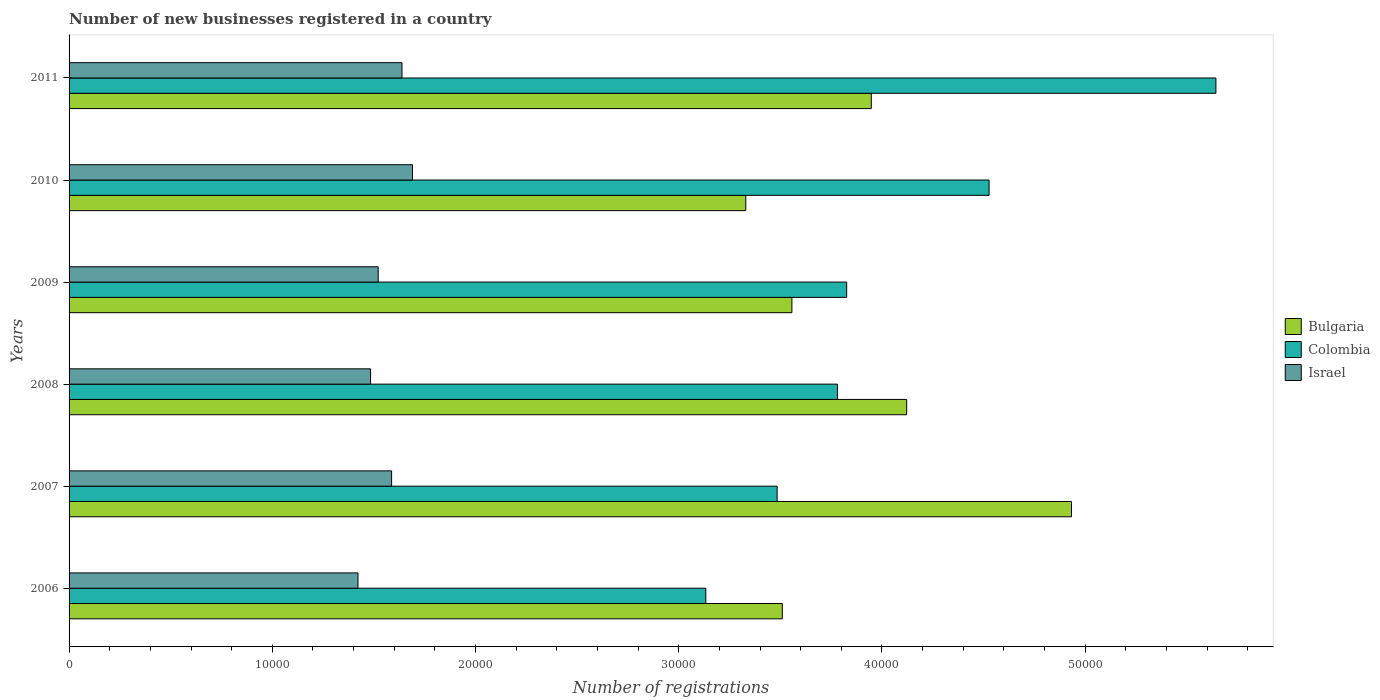How many different coloured bars are there?
Your answer should be very brief. 3. Are the number of bars on each tick of the Y-axis equal?
Ensure brevity in your answer.  Yes. How many bars are there on the 2nd tick from the bottom?
Your answer should be compact. 3. What is the number of new businesses registered in Colombia in 2007?
Offer a very short reply. 3.48e+04. Across all years, what is the maximum number of new businesses registered in Bulgaria?
Your answer should be very brief. 4.93e+04. Across all years, what is the minimum number of new businesses registered in Israel?
Your answer should be compact. 1.42e+04. In which year was the number of new businesses registered in Bulgaria maximum?
Provide a short and direct response. 2007. In which year was the number of new businesses registered in Israel minimum?
Your answer should be very brief. 2006. What is the total number of new businesses registered in Colombia in the graph?
Make the answer very short. 2.44e+05. What is the difference between the number of new businesses registered in Colombia in 2009 and that in 2010?
Ensure brevity in your answer.  -7008. What is the difference between the number of new businesses registered in Israel in 2010 and the number of new businesses registered in Bulgaria in 2007?
Your answer should be compact. -3.24e+04. What is the average number of new businesses registered in Israel per year?
Your response must be concise. 1.56e+04. In the year 2008, what is the difference between the number of new businesses registered in Colombia and number of new businesses registered in Israel?
Make the answer very short. 2.30e+04. In how many years, is the number of new businesses registered in Colombia greater than 6000 ?
Provide a short and direct response. 6. What is the ratio of the number of new businesses registered in Bulgaria in 2007 to that in 2009?
Your answer should be compact. 1.39. Is the number of new businesses registered in Israel in 2006 less than that in 2011?
Ensure brevity in your answer.  Yes. Is the difference between the number of new businesses registered in Colombia in 2007 and 2011 greater than the difference between the number of new businesses registered in Israel in 2007 and 2011?
Make the answer very short. No. What is the difference between the highest and the second highest number of new businesses registered in Colombia?
Provide a short and direct response. 1.12e+04. What is the difference between the highest and the lowest number of new businesses registered in Israel?
Make the answer very short. 2681. In how many years, is the number of new businesses registered in Israel greater than the average number of new businesses registered in Israel taken over all years?
Provide a succinct answer. 3. Are all the bars in the graph horizontal?
Make the answer very short. Yes. What is the difference between two consecutive major ticks on the X-axis?
Make the answer very short. 10000. Are the values on the major ticks of X-axis written in scientific E-notation?
Keep it short and to the point. No. Does the graph contain grids?
Make the answer very short. No. Where does the legend appear in the graph?
Offer a terse response. Center right. How many legend labels are there?
Ensure brevity in your answer.  3. What is the title of the graph?
Provide a succinct answer. Number of new businesses registered in a country. Does "Barbados" appear as one of the legend labels in the graph?
Offer a terse response. No. What is the label or title of the X-axis?
Your answer should be compact. Number of registrations. What is the label or title of the Y-axis?
Your response must be concise. Years. What is the Number of registrations of Bulgaria in 2006?
Offer a very short reply. 3.51e+04. What is the Number of registrations of Colombia in 2006?
Your answer should be compact. 3.13e+04. What is the Number of registrations of Israel in 2006?
Your response must be concise. 1.42e+04. What is the Number of registrations of Bulgaria in 2007?
Your answer should be compact. 4.93e+04. What is the Number of registrations in Colombia in 2007?
Provide a short and direct response. 3.48e+04. What is the Number of registrations in Israel in 2007?
Offer a terse response. 1.59e+04. What is the Number of registrations in Bulgaria in 2008?
Make the answer very short. 4.12e+04. What is the Number of registrations in Colombia in 2008?
Your answer should be very brief. 3.78e+04. What is the Number of registrations of Israel in 2008?
Give a very brief answer. 1.48e+04. What is the Number of registrations in Bulgaria in 2009?
Ensure brevity in your answer.  3.56e+04. What is the Number of registrations in Colombia in 2009?
Your answer should be very brief. 3.83e+04. What is the Number of registrations in Israel in 2009?
Your answer should be compact. 1.52e+04. What is the Number of registrations in Bulgaria in 2010?
Keep it short and to the point. 3.33e+04. What is the Number of registrations in Colombia in 2010?
Offer a terse response. 4.53e+04. What is the Number of registrations of Israel in 2010?
Make the answer very short. 1.69e+04. What is the Number of registrations in Bulgaria in 2011?
Keep it short and to the point. 3.95e+04. What is the Number of registrations in Colombia in 2011?
Offer a terse response. 5.64e+04. What is the Number of registrations in Israel in 2011?
Offer a very short reply. 1.64e+04. Across all years, what is the maximum Number of registrations of Bulgaria?
Provide a short and direct response. 4.93e+04. Across all years, what is the maximum Number of registrations of Colombia?
Offer a very short reply. 5.64e+04. Across all years, what is the maximum Number of registrations in Israel?
Your answer should be very brief. 1.69e+04. Across all years, what is the minimum Number of registrations in Bulgaria?
Keep it short and to the point. 3.33e+04. Across all years, what is the minimum Number of registrations of Colombia?
Your answer should be very brief. 3.13e+04. Across all years, what is the minimum Number of registrations of Israel?
Keep it short and to the point. 1.42e+04. What is the total Number of registrations in Bulgaria in the graph?
Keep it short and to the point. 2.34e+05. What is the total Number of registrations of Colombia in the graph?
Your response must be concise. 2.44e+05. What is the total Number of registrations of Israel in the graph?
Your response must be concise. 9.34e+04. What is the difference between the Number of registrations of Bulgaria in 2006 and that in 2007?
Provide a short and direct response. -1.42e+04. What is the difference between the Number of registrations in Colombia in 2006 and that in 2007?
Ensure brevity in your answer.  -3510. What is the difference between the Number of registrations in Israel in 2006 and that in 2007?
Offer a very short reply. -1654. What is the difference between the Number of registrations of Bulgaria in 2006 and that in 2008?
Offer a terse response. -6120. What is the difference between the Number of registrations of Colombia in 2006 and that in 2008?
Offer a very short reply. -6477. What is the difference between the Number of registrations in Israel in 2006 and that in 2008?
Make the answer very short. -619. What is the difference between the Number of registrations in Bulgaria in 2006 and that in 2009?
Your response must be concise. -472. What is the difference between the Number of registrations in Colombia in 2006 and that in 2009?
Make the answer very short. -6932. What is the difference between the Number of registrations in Israel in 2006 and that in 2009?
Make the answer very short. -994. What is the difference between the Number of registrations in Bulgaria in 2006 and that in 2010?
Your answer should be compact. 1798. What is the difference between the Number of registrations of Colombia in 2006 and that in 2010?
Your answer should be very brief. -1.39e+04. What is the difference between the Number of registrations in Israel in 2006 and that in 2010?
Provide a short and direct response. -2681. What is the difference between the Number of registrations of Bulgaria in 2006 and that in 2011?
Your answer should be very brief. -4378. What is the difference between the Number of registrations of Colombia in 2006 and that in 2011?
Keep it short and to the point. -2.51e+04. What is the difference between the Number of registrations in Israel in 2006 and that in 2011?
Make the answer very short. -2166. What is the difference between the Number of registrations in Bulgaria in 2007 and that in 2008?
Provide a succinct answer. 8110. What is the difference between the Number of registrations in Colombia in 2007 and that in 2008?
Keep it short and to the point. -2967. What is the difference between the Number of registrations of Israel in 2007 and that in 2008?
Your answer should be compact. 1035. What is the difference between the Number of registrations of Bulgaria in 2007 and that in 2009?
Ensure brevity in your answer.  1.38e+04. What is the difference between the Number of registrations of Colombia in 2007 and that in 2009?
Offer a very short reply. -3422. What is the difference between the Number of registrations in Israel in 2007 and that in 2009?
Provide a short and direct response. 660. What is the difference between the Number of registrations in Bulgaria in 2007 and that in 2010?
Make the answer very short. 1.60e+04. What is the difference between the Number of registrations in Colombia in 2007 and that in 2010?
Offer a very short reply. -1.04e+04. What is the difference between the Number of registrations in Israel in 2007 and that in 2010?
Provide a succinct answer. -1027. What is the difference between the Number of registrations of Bulgaria in 2007 and that in 2011?
Keep it short and to the point. 9852. What is the difference between the Number of registrations of Colombia in 2007 and that in 2011?
Your answer should be compact. -2.16e+04. What is the difference between the Number of registrations in Israel in 2007 and that in 2011?
Your answer should be compact. -512. What is the difference between the Number of registrations in Bulgaria in 2008 and that in 2009?
Ensure brevity in your answer.  5648. What is the difference between the Number of registrations in Colombia in 2008 and that in 2009?
Give a very brief answer. -455. What is the difference between the Number of registrations of Israel in 2008 and that in 2009?
Ensure brevity in your answer.  -375. What is the difference between the Number of registrations in Bulgaria in 2008 and that in 2010?
Offer a very short reply. 7918. What is the difference between the Number of registrations in Colombia in 2008 and that in 2010?
Your response must be concise. -7463. What is the difference between the Number of registrations in Israel in 2008 and that in 2010?
Ensure brevity in your answer.  -2062. What is the difference between the Number of registrations in Bulgaria in 2008 and that in 2011?
Offer a very short reply. 1742. What is the difference between the Number of registrations in Colombia in 2008 and that in 2011?
Provide a succinct answer. -1.86e+04. What is the difference between the Number of registrations in Israel in 2008 and that in 2011?
Make the answer very short. -1547. What is the difference between the Number of registrations in Bulgaria in 2009 and that in 2010?
Provide a succinct answer. 2270. What is the difference between the Number of registrations in Colombia in 2009 and that in 2010?
Offer a terse response. -7008. What is the difference between the Number of registrations in Israel in 2009 and that in 2010?
Your answer should be compact. -1687. What is the difference between the Number of registrations in Bulgaria in 2009 and that in 2011?
Ensure brevity in your answer.  -3906. What is the difference between the Number of registrations of Colombia in 2009 and that in 2011?
Provide a short and direct response. -1.82e+04. What is the difference between the Number of registrations of Israel in 2009 and that in 2011?
Offer a very short reply. -1172. What is the difference between the Number of registrations in Bulgaria in 2010 and that in 2011?
Give a very brief answer. -6176. What is the difference between the Number of registrations in Colombia in 2010 and that in 2011?
Offer a terse response. -1.12e+04. What is the difference between the Number of registrations in Israel in 2010 and that in 2011?
Offer a terse response. 515. What is the difference between the Number of registrations of Bulgaria in 2006 and the Number of registrations of Colombia in 2007?
Offer a terse response. 255. What is the difference between the Number of registrations in Bulgaria in 2006 and the Number of registrations in Israel in 2007?
Give a very brief answer. 1.92e+04. What is the difference between the Number of registrations of Colombia in 2006 and the Number of registrations of Israel in 2007?
Your answer should be very brief. 1.55e+04. What is the difference between the Number of registrations of Bulgaria in 2006 and the Number of registrations of Colombia in 2008?
Provide a succinct answer. -2712. What is the difference between the Number of registrations of Bulgaria in 2006 and the Number of registrations of Israel in 2008?
Ensure brevity in your answer.  2.03e+04. What is the difference between the Number of registrations in Colombia in 2006 and the Number of registrations in Israel in 2008?
Ensure brevity in your answer.  1.65e+04. What is the difference between the Number of registrations in Bulgaria in 2006 and the Number of registrations in Colombia in 2009?
Provide a succinct answer. -3167. What is the difference between the Number of registrations of Bulgaria in 2006 and the Number of registrations of Israel in 2009?
Offer a very short reply. 1.99e+04. What is the difference between the Number of registrations in Colombia in 2006 and the Number of registrations in Israel in 2009?
Keep it short and to the point. 1.61e+04. What is the difference between the Number of registrations in Bulgaria in 2006 and the Number of registrations in Colombia in 2010?
Your answer should be very brief. -1.02e+04. What is the difference between the Number of registrations in Bulgaria in 2006 and the Number of registrations in Israel in 2010?
Your answer should be very brief. 1.82e+04. What is the difference between the Number of registrations in Colombia in 2006 and the Number of registrations in Israel in 2010?
Offer a very short reply. 1.44e+04. What is the difference between the Number of registrations in Bulgaria in 2006 and the Number of registrations in Colombia in 2011?
Your response must be concise. -2.13e+04. What is the difference between the Number of registrations of Bulgaria in 2006 and the Number of registrations of Israel in 2011?
Your answer should be very brief. 1.87e+04. What is the difference between the Number of registrations in Colombia in 2006 and the Number of registrations in Israel in 2011?
Ensure brevity in your answer.  1.50e+04. What is the difference between the Number of registrations of Bulgaria in 2007 and the Number of registrations of Colombia in 2008?
Make the answer very short. 1.15e+04. What is the difference between the Number of registrations of Bulgaria in 2007 and the Number of registrations of Israel in 2008?
Give a very brief answer. 3.45e+04. What is the difference between the Number of registrations in Colombia in 2007 and the Number of registrations in Israel in 2008?
Provide a succinct answer. 2.00e+04. What is the difference between the Number of registrations of Bulgaria in 2007 and the Number of registrations of Colombia in 2009?
Give a very brief answer. 1.11e+04. What is the difference between the Number of registrations of Bulgaria in 2007 and the Number of registrations of Israel in 2009?
Offer a very short reply. 3.41e+04. What is the difference between the Number of registrations of Colombia in 2007 and the Number of registrations of Israel in 2009?
Offer a very short reply. 1.96e+04. What is the difference between the Number of registrations of Bulgaria in 2007 and the Number of registrations of Colombia in 2010?
Offer a very short reply. 4055. What is the difference between the Number of registrations of Bulgaria in 2007 and the Number of registrations of Israel in 2010?
Offer a terse response. 3.24e+04. What is the difference between the Number of registrations of Colombia in 2007 and the Number of registrations of Israel in 2010?
Provide a succinct answer. 1.79e+04. What is the difference between the Number of registrations of Bulgaria in 2007 and the Number of registrations of Colombia in 2011?
Offer a terse response. -7106. What is the difference between the Number of registrations of Bulgaria in 2007 and the Number of registrations of Israel in 2011?
Offer a terse response. 3.29e+04. What is the difference between the Number of registrations in Colombia in 2007 and the Number of registrations in Israel in 2011?
Ensure brevity in your answer.  1.85e+04. What is the difference between the Number of registrations of Bulgaria in 2008 and the Number of registrations of Colombia in 2009?
Keep it short and to the point. 2953. What is the difference between the Number of registrations in Bulgaria in 2008 and the Number of registrations in Israel in 2009?
Your response must be concise. 2.60e+04. What is the difference between the Number of registrations in Colombia in 2008 and the Number of registrations in Israel in 2009?
Make the answer very short. 2.26e+04. What is the difference between the Number of registrations of Bulgaria in 2008 and the Number of registrations of Colombia in 2010?
Provide a short and direct response. -4055. What is the difference between the Number of registrations of Bulgaria in 2008 and the Number of registrations of Israel in 2010?
Provide a succinct answer. 2.43e+04. What is the difference between the Number of registrations of Colombia in 2008 and the Number of registrations of Israel in 2010?
Keep it short and to the point. 2.09e+04. What is the difference between the Number of registrations of Bulgaria in 2008 and the Number of registrations of Colombia in 2011?
Keep it short and to the point. -1.52e+04. What is the difference between the Number of registrations of Bulgaria in 2008 and the Number of registrations of Israel in 2011?
Provide a succinct answer. 2.48e+04. What is the difference between the Number of registrations of Colombia in 2008 and the Number of registrations of Israel in 2011?
Your answer should be very brief. 2.14e+04. What is the difference between the Number of registrations in Bulgaria in 2009 and the Number of registrations in Colombia in 2010?
Your response must be concise. -9703. What is the difference between the Number of registrations of Bulgaria in 2009 and the Number of registrations of Israel in 2010?
Make the answer very short. 1.87e+04. What is the difference between the Number of registrations of Colombia in 2009 and the Number of registrations of Israel in 2010?
Your answer should be compact. 2.14e+04. What is the difference between the Number of registrations of Bulgaria in 2009 and the Number of registrations of Colombia in 2011?
Give a very brief answer. -2.09e+04. What is the difference between the Number of registrations in Bulgaria in 2009 and the Number of registrations in Israel in 2011?
Offer a very short reply. 1.92e+04. What is the difference between the Number of registrations of Colombia in 2009 and the Number of registrations of Israel in 2011?
Provide a succinct answer. 2.19e+04. What is the difference between the Number of registrations in Bulgaria in 2010 and the Number of registrations in Colombia in 2011?
Provide a succinct answer. -2.31e+04. What is the difference between the Number of registrations in Bulgaria in 2010 and the Number of registrations in Israel in 2011?
Offer a very short reply. 1.69e+04. What is the difference between the Number of registrations in Colombia in 2010 and the Number of registrations in Israel in 2011?
Your answer should be very brief. 2.89e+04. What is the average Number of registrations of Bulgaria per year?
Keep it short and to the point. 3.90e+04. What is the average Number of registrations in Colombia per year?
Make the answer very short. 4.07e+04. What is the average Number of registrations of Israel per year?
Give a very brief answer. 1.56e+04. In the year 2006, what is the difference between the Number of registrations in Bulgaria and Number of registrations in Colombia?
Offer a very short reply. 3765. In the year 2006, what is the difference between the Number of registrations of Bulgaria and Number of registrations of Israel?
Ensure brevity in your answer.  2.09e+04. In the year 2006, what is the difference between the Number of registrations in Colombia and Number of registrations in Israel?
Offer a terse response. 1.71e+04. In the year 2007, what is the difference between the Number of registrations of Bulgaria and Number of registrations of Colombia?
Your answer should be very brief. 1.45e+04. In the year 2007, what is the difference between the Number of registrations of Bulgaria and Number of registrations of Israel?
Provide a succinct answer. 3.35e+04. In the year 2007, what is the difference between the Number of registrations of Colombia and Number of registrations of Israel?
Make the answer very short. 1.90e+04. In the year 2008, what is the difference between the Number of registrations in Bulgaria and Number of registrations in Colombia?
Ensure brevity in your answer.  3408. In the year 2008, what is the difference between the Number of registrations in Bulgaria and Number of registrations in Israel?
Ensure brevity in your answer.  2.64e+04. In the year 2008, what is the difference between the Number of registrations in Colombia and Number of registrations in Israel?
Keep it short and to the point. 2.30e+04. In the year 2009, what is the difference between the Number of registrations of Bulgaria and Number of registrations of Colombia?
Your response must be concise. -2695. In the year 2009, what is the difference between the Number of registrations in Bulgaria and Number of registrations in Israel?
Ensure brevity in your answer.  2.04e+04. In the year 2009, what is the difference between the Number of registrations of Colombia and Number of registrations of Israel?
Keep it short and to the point. 2.31e+04. In the year 2010, what is the difference between the Number of registrations of Bulgaria and Number of registrations of Colombia?
Provide a short and direct response. -1.20e+04. In the year 2010, what is the difference between the Number of registrations in Bulgaria and Number of registrations in Israel?
Provide a short and direct response. 1.64e+04. In the year 2010, what is the difference between the Number of registrations in Colombia and Number of registrations in Israel?
Offer a very short reply. 2.84e+04. In the year 2011, what is the difference between the Number of registrations of Bulgaria and Number of registrations of Colombia?
Your answer should be compact. -1.70e+04. In the year 2011, what is the difference between the Number of registrations in Bulgaria and Number of registrations in Israel?
Keep it short and to the point. 2.31e+04. In the year 2011, what is the difference between the Number of registrations in Colombia and Number of registrations in Israel?
Your response must be concise. 4.01e+04. What is the ratio of the Number of registrations in Bulgaria in 2006 to that in 2007?
Your response must be concise. 0.71. What is the ratio of the Number of registrations of Colombia in 2006 to that in 2007?
Ensure brevity in your answer.  0.9. What is the ratio of the Number of registrations in Israel in 2006 to that in 2007?
Keep it short and to the point. 0.9. What is the ratio of the Number of registrations in Bulgaria in 2006 to that in 2008?
Make the answer very short. 0.85. What is the ratio of the Number of registrations in Colombia in 2006 to that in 2008?
Offer a terse response. 0.83. What is the ratio of the Number of registrations in Israel in 2006 to that in 2008?
Provide a succinct answer. 0.96. What is the ratio of the Number of registrations of Bulgaria in 2006 to that in 2009?
Your response must be concise. 0.99. What is the ratio of the Number of registrations in Colombia in 2006 to that in 2009?
Make the answer very short. 0.82. What is the ratio of the Number of registrations of Israel in 2006 to that in 2009?
Provide a short and direct response. 0.93. What is the ratio of the Number of registrations in Bulgaria in 2006 to that in 2010?
Offer a very short reply. 1.05. What is the ratio of the Number of registrations in Colombia in 2006 to that in 2010?
Make the answer very short. 0.69. What is the ratio of the Number of registrations of Israel in 2006 to that in 2010?
Offer a terse response. 0.84. What is the ratio of the Number of registrations in Bulgaria in 2006 to that in 2011?
Provide a short and direct response. 0.89. What is the ratio of the Number of registrations of Colombia in 2006 to that in 2011?
Offer a terse response. 0.56. What is the ratio of the Number of registrations in Israel in 2006 to that in 2011?
Ensure brevity in your answer.  0.87. What is the ratio of the Number of registrations in Bulgaria in 2007 to that in 2008?
Ensure brevity in your answer.  1.2. What is the ratio of the Number of registrations in Colombia in 2007 to that in 2008?
Ensure brevity in your answer.  0.92. What is the ratio of the Number of registrations in Israel in 2007 to that in 2008?
Offer a very short reply. 1.07. What is the ratio of the Number of registrations of Bulgaria in 2007 to that in 2009?
Offer a very short reply. 1.39. What is the ratio of the Number of registrations in Colombia in 2007 to that in 2009?
Provide a succinct answer. 0.91. What is the ratio of the Number of registrations in Israel in 2007 to that in 2009?
Your response must be concise. 1.04. What is the ratio of the Number of registrations in Bulgaria in 2007 to that in 2010?
Your answer should be very brief. 1.48. What is the ratio of the Number of registrations of Colombia in 2007 to that in 2010?
Your answer should be compact. 0.77. What is the ratio of the Number of registrations in Israel in 2007 to that in 2010?
Offer a very short reply. 0.94. What is the ratio of the Number of registrations in Bulgaria in 2007 to that in 2011?
Ensure brevity in your answer.  1.25. What is the ratio of the Number of registrations of Colombia in 2007 to that in 2011?
Offer a terse response. 0.62. What is the ratio of the Number of registrations in Israel in 2007 to that in 2011?
Offer a terse response. 0.97. What is the ratio of the Number of registrations in Bulgaria in 2008 to that in 2009?
Give a very brief answer. 1.16. What is the ratio of the Number of registrations in Israel in 2008 to that in 2009?
Offer a terse response. 0.98. What is the ratio of the Number of registrations of Bulgaria in 2008 to that in 2010?
Make the answer very short. 1.24. What is the ratio of the Number of registrations in Colombia in 2008 to that in 2010?
Provide a succinct answer. 0.84. What is the ratio of the Number of registrations in Israel in 2008 to that in 2010?
Keep it short and to the point. 0.88. What is the ratio of the Number of registrations of Bulgaria in 2008 to that in 2011?
Give a very brief answer. 1.04. What is the ratio of the Number of registrations in Colombia in 2008 to that in 2011?
Ensure brevity in your answer.  0.67. What is the ratio of the Number of registrations of Israel in 2008 to that in 2011?
Provide a short and direct response. 0.91. What is the ratio of the Number of registrations of Bulgaria in 2009 to that in 2010?
Your response must be concise. 1.07. What is the ratio of the Number of registrations of Colombia in 2009 to that in 2010?
Give a very brief answer. 0.85. What is the ratio of the Number of registrations of Israel in 2009 to that in 2010?
Offer a terse response. 0.9. What is the ratio of the Number of registrations of Bulgaria in 2009 to that in 2011?
Your answer should be compact. 0.9. What is the ratio of the Number of registrations of Colombia in 2009 to that in 2011?
Keep it short and to the point. 0.68. What is the ratio of the Number of registrations of Israel in 2009 to that in 2011?
Provide a short and direct response. 0.93. What is the ratio of the Number of registrations of Bulgaria in 2010 to that in 2011?
Ensure brevity in your answer.  0.84. What is the ratio of the Number of registrations of Colombia in 2010 to that in 2011?
Provide a short and direct response. 0.8. What is the ratio of the Number of registrations of Israel in 2010 to that in 2011?
Your answer should be compact. 1.03. What is the difference between the highest and the second highest Number of registrations of Bulgaria?
Offer a very short reply. 8110. What is the difference between the highest and the second highest Number of registrations in Colombia?
Your answer should be compact. 1.12e+04. What is the difference between the highest and the second highest Number of registrations in Israel?
Your answer should be very brief. 515. What is the difference between the highest and the lowest Number of registrations in Bulgaria?
Your answer should be very brief. 1.60e+04. What is the difference between the highest and the lowest Number of registrations of Colombia?
Your response must be concise. 2.51e+04. What is the difference between the highest and the lowest Number of registrations of Israel?
Your response must be concise. 2681. 